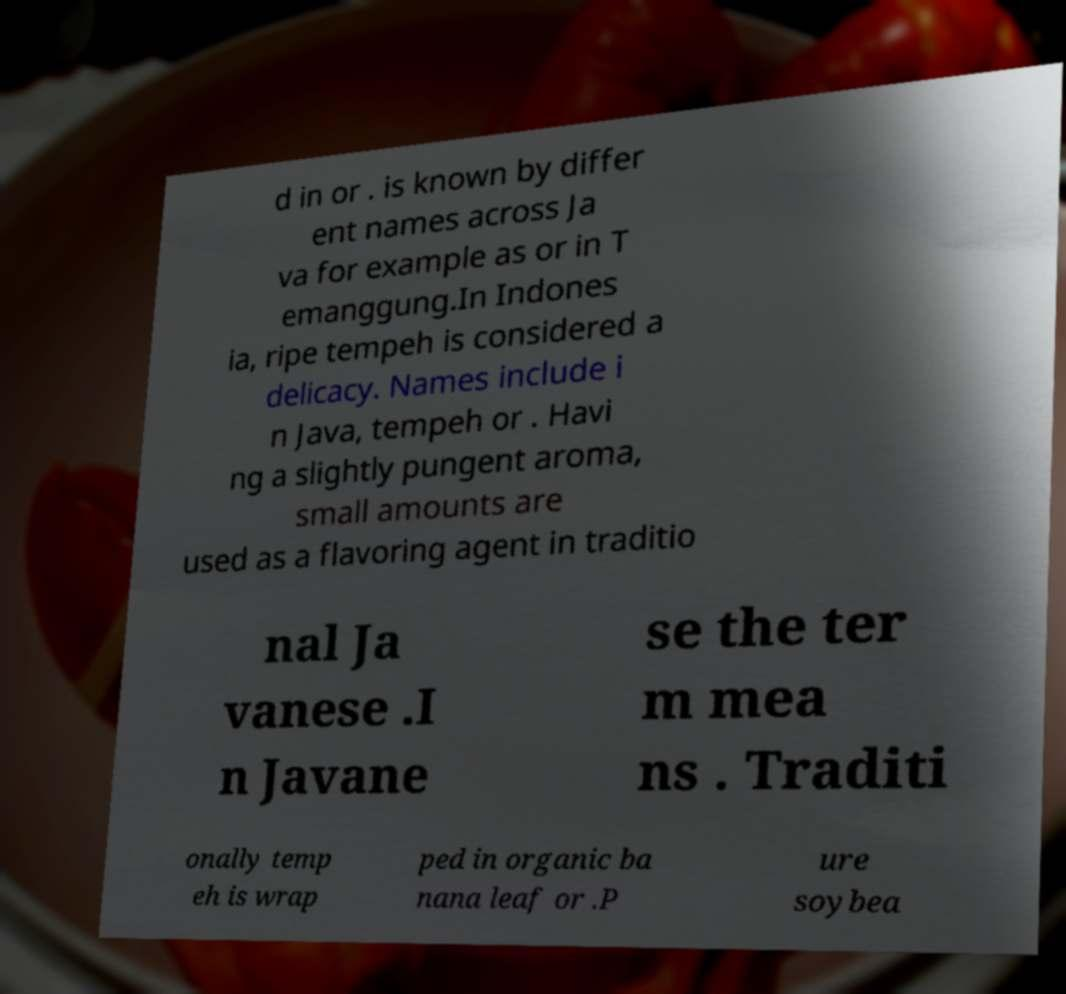Could you assist in decoding the text presented in this image and type it out clearly? d in or . is known by differ ent names across Ja va for example as or in T emanggung.In Indones ia, ripe tempeh is considered a delicacy. Names include i n Java, tempeh or . Havi ng a slightly pungent aroma, small amounts are used as a flavoring agent in traditio nal Ja vanese .I n Javane se the ter m mea ns . Traditi onally temp eh is wrap ped in organic ba nana leaf or .P ure soybea 